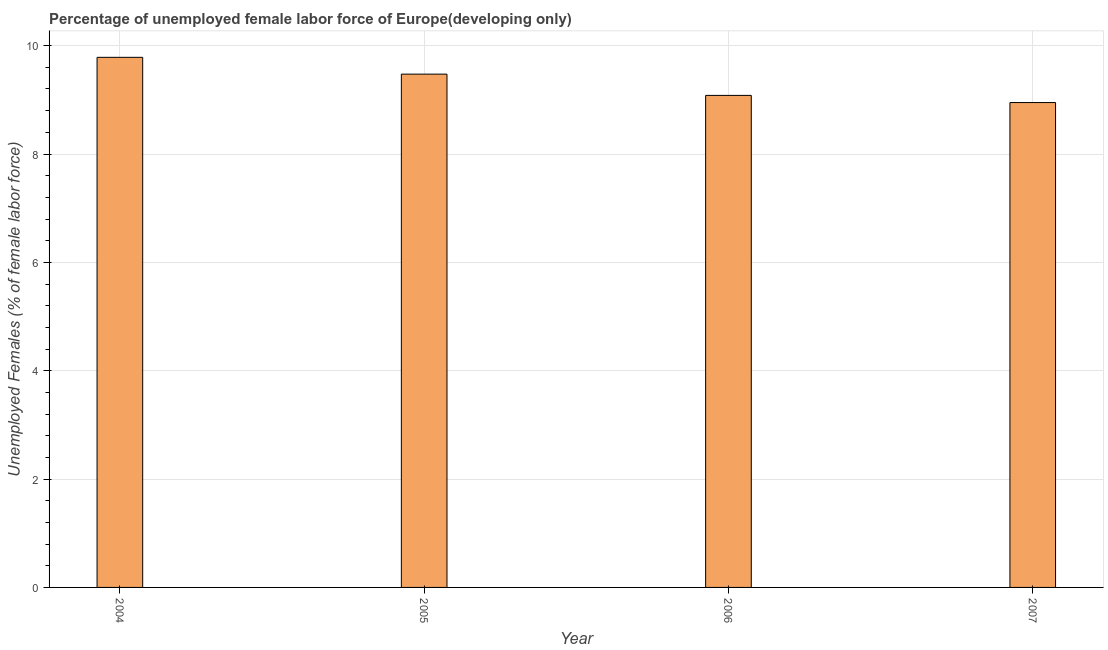What is the title of the graph?
Your answer should be compact. Percentage of unemployed female labor force of Europe(developing only). What is the label or title of the X-axis?
Your answer should be compact. Year. What is the label or title of the Y-axis?
Offer a very short reply. Unemployed Females (% of female labor force). What is the total unemployed female labour force in 2005?
Ensure brevity in your answer.  9.47. Across all years, what is the maximum total unemployed female labour force?
Offer a very short reply. 9.78. Across all years, what is the minimum total unemployed female labour force?
Offer a terse response. 8.95. In which year was the total unemployed female labour force maximum?
Provide a short and direct response. 2004. In which year was the total unemployed female labour force minimum?
Offer a very short reply. 2007. What is the sum of the total unemployed female labour force?
Offer a terse response. 37.29. What is the difference between the total unemployed female labour force in 2005 and 2007?
Provide a succinct answer. 0.53. What is the average total unemployed female labour force per year?
Your answer should be compact. 9.32. What is the median total unemployed female labour force?
Offer a terse response. 9.28. In how many years, is the total unemployed female labour force greater than 5.6 %?
Your response must be concise. 4. Do a majority of the years between 2007 and 2005 (inclusive) have total unemployed female labour force greater than 4.4 %?
Offer a very short reply. Yes. What is the ratio of the total unemployed female labour force in 2006 to that in 2007?
Ensure brevity in your answer.  1.01. Is the total unemployed female labour force in 2005 less than that in 2007?
Offer a very short reply. No. What is the difference between the highest and the second highest total unemployed female labour force?
Ensure brevity in your answer.  0.31. What is the difference between the highest and the lowest total unemployed female labour force?
Provide a succinct answer. 0.83. Are all the bars in the graph horizontal?
Your response must be concise. No. What is the difference between two consecutive major ticks on the Y-axis?
Your answer should be very brief. 2. What is the Unemployed Females (% of female labor force) in 2004?
Your response must be concise. 9.78. What is the Unemployed Females (% of female labor force) in 2005?
Make the answer very short. 9.47. What is the Unemployed Females (% of female labor force) of 2006?
Keep it short and to the point. 9.08. What is the Unemployed Females (% of female labor force) of 2007?
Offer a very short reply. 8.95. What is the difference between the Unemployed Females (% of female labor force) in 2004 and 2005?
Make the answer very short. 0.31. What is the difference between the Unemployed Females (% of female labor force) in 2004 and 2006?
Your answer should be compact. 0.7. What is the difference between the Unemployed Females (% of female labor force) in 2004 and 2007?
Your answer should be very brief. 0.83. What is the difference between the Unemployed Females (% of female labor force) in 2005 and 2006?
Make the answer very short. 0.39. What is the difference between the Unemployed Females (% of female labor force) in 2005 and 2007?
Offer a very short reply. 0.52. What is the difference between the Unemployed Females (% of female labor force) in 2006 and 2007?
Offer a very short reply. 0.13. What is the ratio of the Unemployed Females (% of female labor force) in 2004 to that in 2005?
Your answer should be very brief. 1.03. What is the ratio of the Unemployed Females (% of female labor force) in 2004 to that in 2006?
Keep it short and to the point. 1.08. What is the ratio of the Unemployed Females (% of female labor force) in 2004 to that in 2007?
Your answer should be very brief. 1.09. What is the ratio of the Unemployed Females (% of female labor force) in 2005 to that in 2006?
Your answer should be compact. 1.04. What is the ratio of the Unemployed Females (% of female labor force) in 2005 to that in 2007?
Offer a very short reply. 1.06. What is the ratio of the Unemployed Females (% of female labor force) in 2006 to that in 2007?
Make the answer very short. 1.01. 